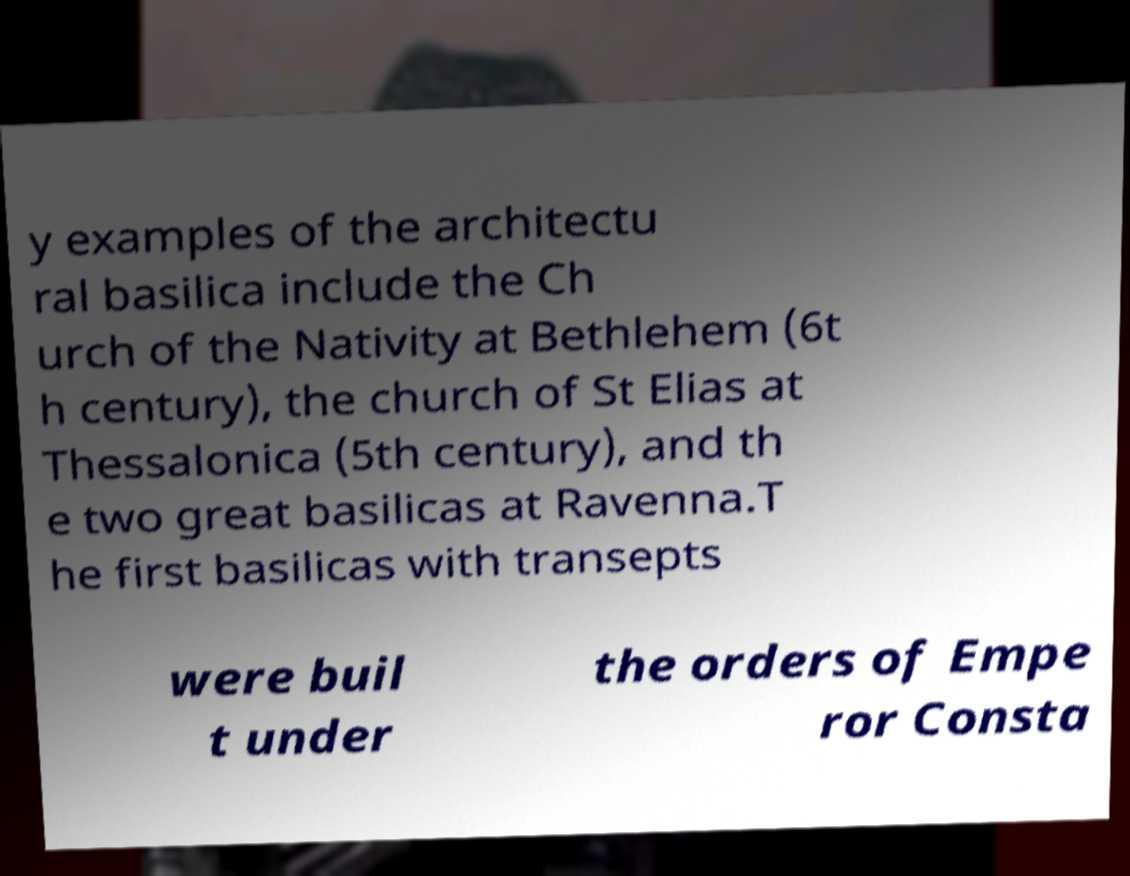What messages or text are displayed in this image? I need them in a readable, typed format. y examples of the architectu ral basilica include the Ch urch of the Nativity at Bethlehem (6t h century), the church of St Elias at Thessalonica (5th century), and th e two great basilicas at Ravenna.T he first basilicas with transepts were buil t under the orders of Empe ror Consta 